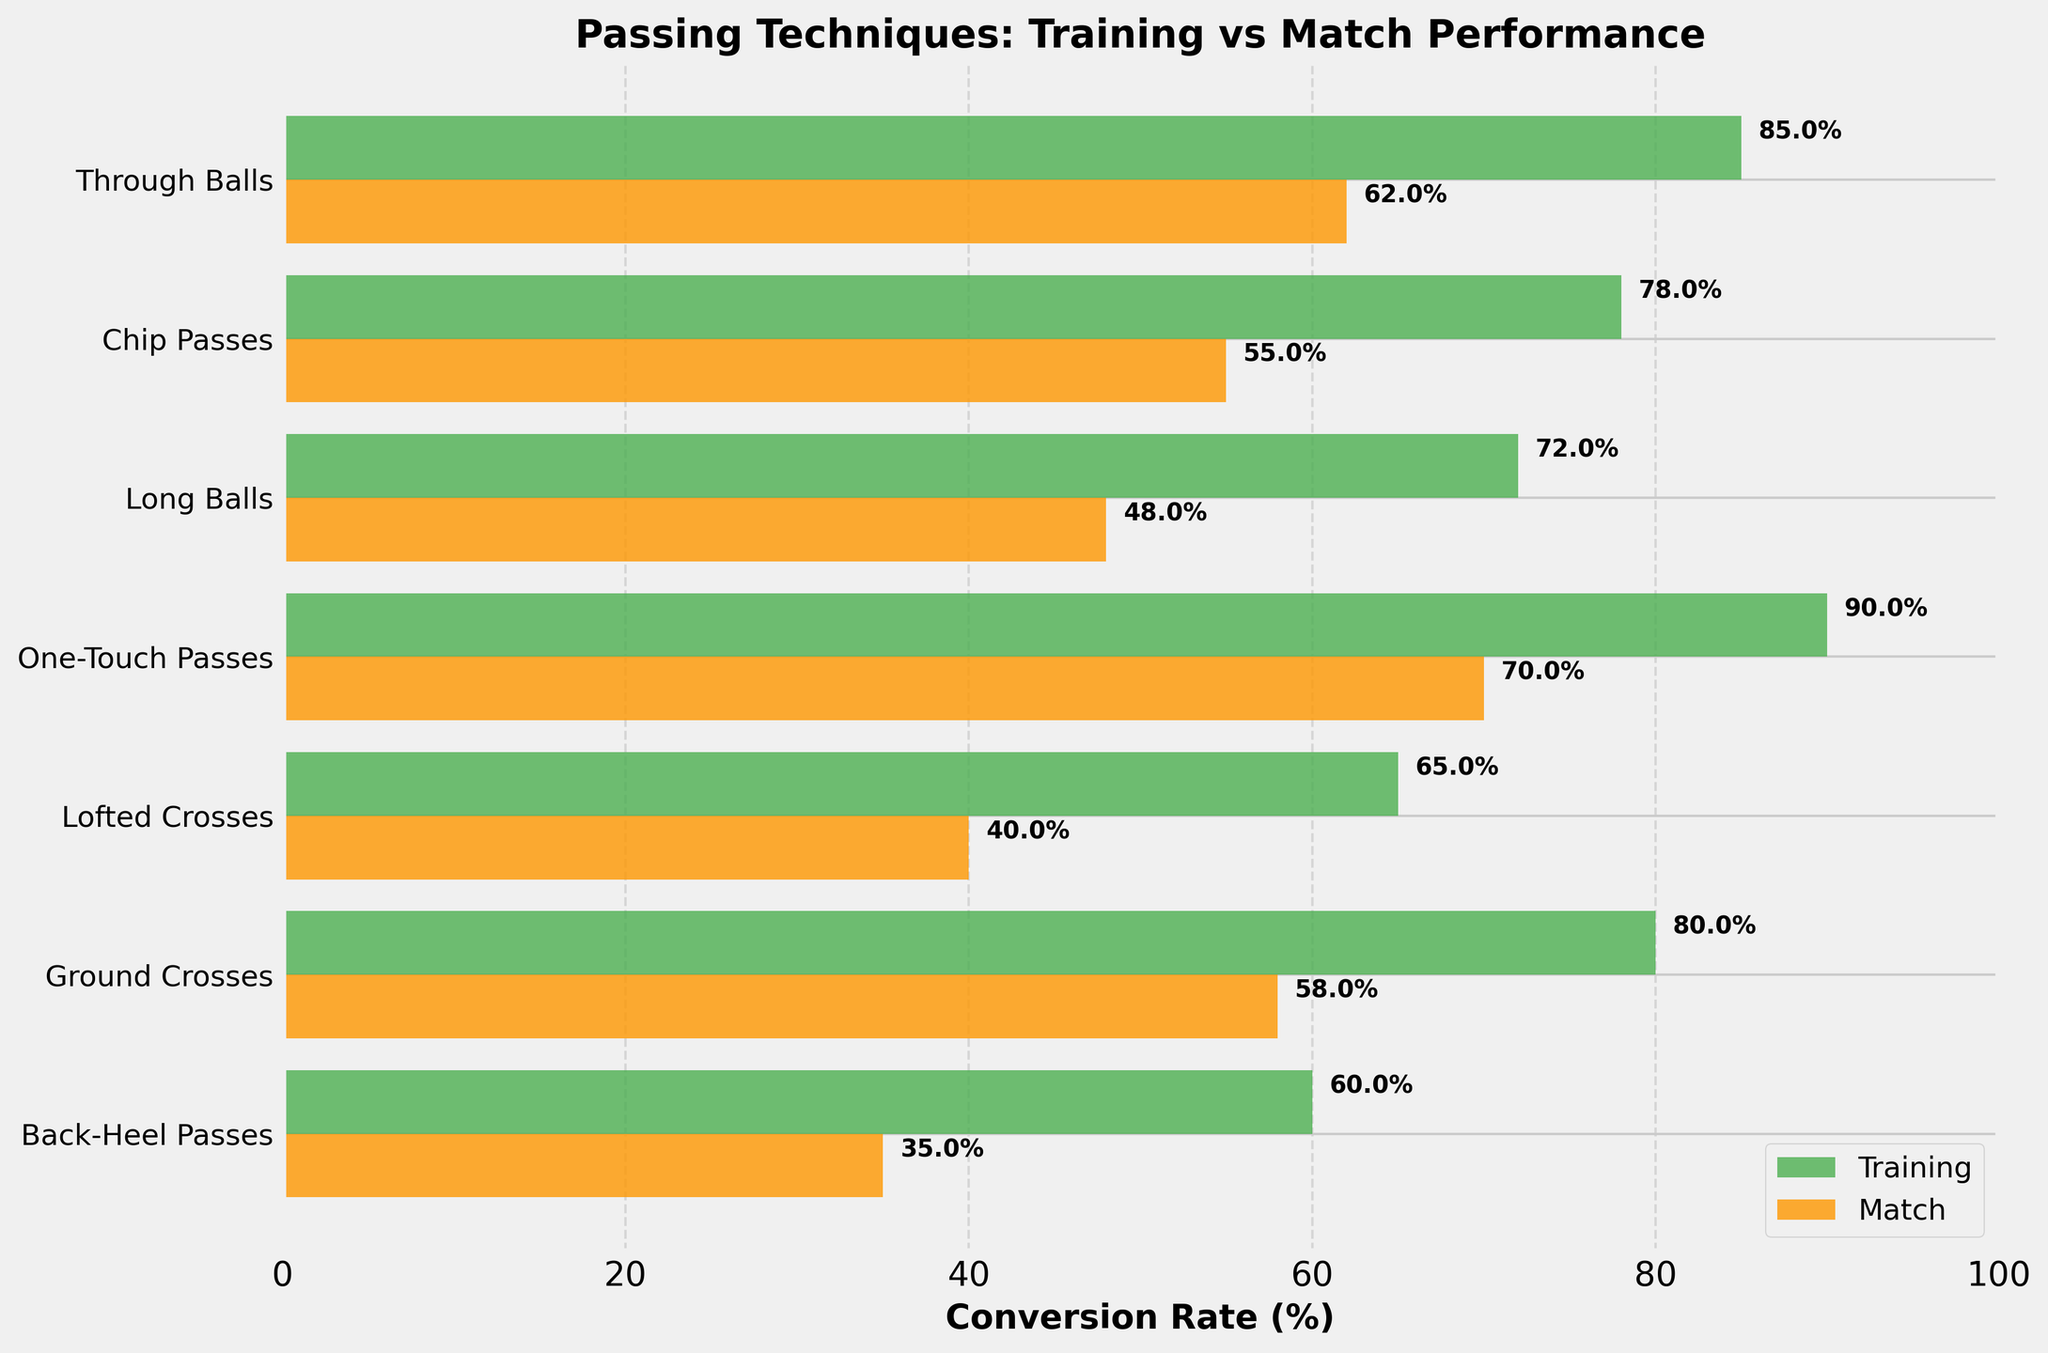What's the title of the figure? The title is located at the top of the figure and it describes the main topic of the chart. It reads, "Passing Techniques: Training vs Match Performance".
Answer: Passing Techniques: Training vs Match Performance What's the conversion rate in matches for Through Balls? Locate the bar representing Through Balls in the match performance section, marked by the orange bar, and read the percentage value next to it.
Answer: 62% Which passing technique has the highest conversion rate during training sessions? Compare all the green bars representing training conversion rates and identify the tallest one, which corresponds to One-Touch Passes with a rate of 90%.
Answer: One-Touch Passes How much lower is the conversion rate of Chip Passes in matches compared to training? Subtract the match conversion rate (55%) from the training conversion rate (78%) for Chip Passes. 78% - 55% = 23%.
Answer: 23% What is the average conversion rate in matches across all techniques? Sum all match conversion rates (62%, 55%, 48%, 70%, 40%, 58%, 35%) and divide by the number of techniques (7). The calculation is (62 + 55 + 48 + 70 + 40 + 58 + 35) / 7 = 52.57%.
Answer: 52.57% Which technique shows the greatest drop in conversion rate from training to matches? Calculate the difference between training and match conversion rates for each technique, then identify the maximum difference. Back-Heel Passes have a difference of 60% - 35% = 25%, the greatest drop among all techniques.
Answer: Back-Heel Passes Are any techniques equally effective in both training and match scenarios? Check if there are any techniques where the green and orange bars are equal in length. There are no techniques with identical conversion rates in both scenarios.
Answer: No Which techniques have a match conversion rate that is less than 50%? Identify the orange bars (match conversion rates) that are less than the 50% mark. These techniques are Long Balls, Lofted Crosses, and Back-Heel Passes.
Answer: Long Balls, Lofted Crosses, Back-Heel Passes What's the conversion rate difference between the best training technique and the worst match technique? Identify the highest training conversion rate (One-Touch Passes, 90%) and the lowest match conversion rate (Back-Heel Passes, 35%), then subtract. 90% - 35% = 55%.
Answer: 55% Between Ground Crosses and Lofted Crosses, which has a higher match performance conversion rate? Compare the orange bars for Ground Crosses (58%) and Lofted Crosses (40%). Ground Crosses have a higher match conversion rate.
Answer: Ground Crosses 